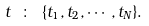<formula> <loc_0><loc_0><loc_500><loc_500>t \ \colon \ \{ t _ { 1 } , t _ { 2 } , \cdots , t _ { N } \} .</formula> 